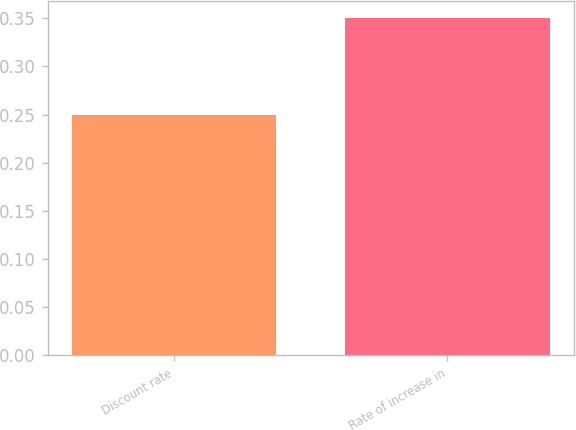<chart> <loc_0><loc_0><loc_500><loc_500><bar_chart><fcel>Discount rate<fcel>Rate of increase in<nl><fcel>0.25<fcel>0.35<nl></chart> 